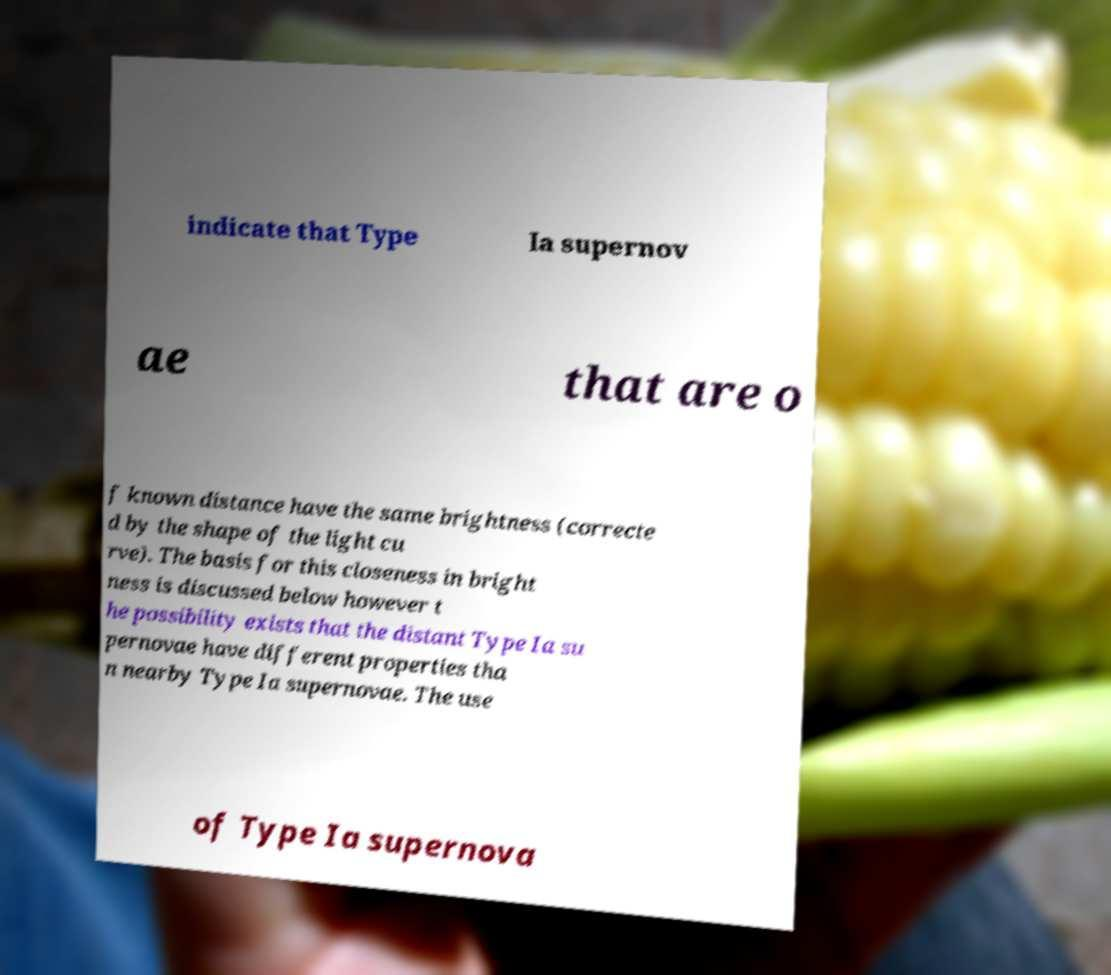What messages or text are displayed in this image? I need them in a readable, typed format. indicate that Type Ia supernov ae that are o f known distance have the same brightness (correcte d by the shape of the light cu rve). The basis for this closeness in bright ness is discussed below however t he possibility exists that the distant Type Ia su pernovae have different properties tha n nearby Type Ia supernovae. The use of Type Ia supernova 